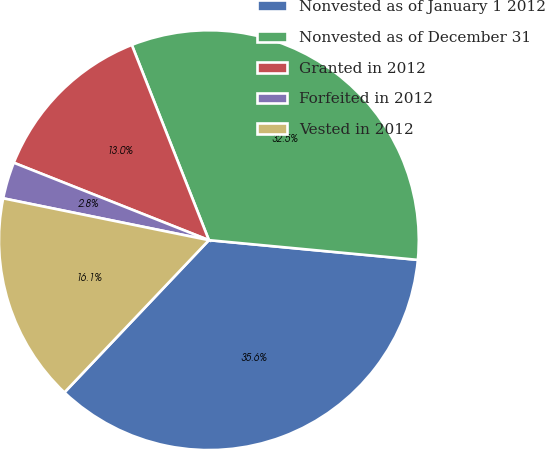Convert chart. <chart><loc_0><loc_0><loc_500><loc_500><pie_chart><fcel>Nonvested as of January 1 2012<fcel>Nonvested as of December 31<fcel>Granted in 2012<fcel>Forfeited in 2012<fcel>Vested in 2012<nl><fcel>35.58%<fcel>32.48%<fcel>13.0%<fcel>2.82%<fcel>16.11%<nl></chart> 